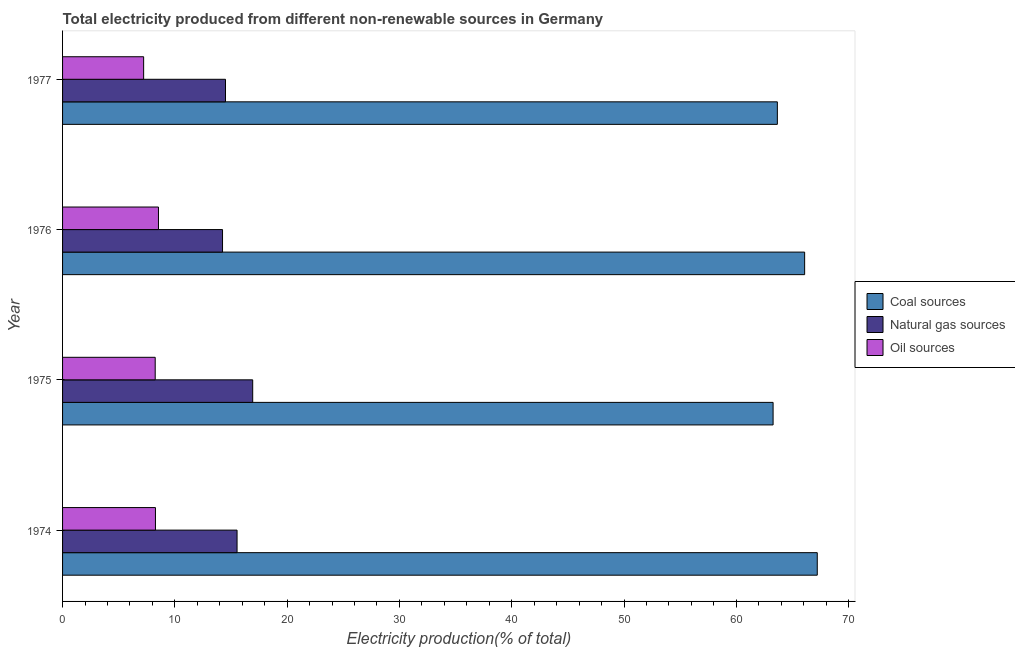How many different coloured bars are there?
Make the answer very short. 3. Are the number of bars per tick equal to the number of legend labels?
Make the answer very short. Yes. How many bars are there on the 1st tick from the top?
Your answer should be very brief. 3. In how many cases, is the number of bars for a given year not equal to the number of legend labels?
Ensure brevity in your answer.  0. What is the percentage of electricity produced by coal in 1974?
Offer a very short reply. 67.21. Across all years, what is the maximum percentage of electricity produced by coal?
Your response must be concise. 67.21. Across all years, what is the minimum percentage of electricity produced by coal?
Provide a short and direct response. 63.27. In which year was the percentage of electricity produced by coal maximum?
Give a very brief answer. 1974. In which year was the percentage of electricity produced by coal minimum?
Provide a short and direct response. 1975. What is the total percentage of electricity produced by coal in the graph?
Make the answer very short. 260.22. What is the difference between the percentage of electricity produced by natural gas in 1975 and the percentage of electricity produced by oil sources in 1977?
Give a very brief answer. 9.71. What is the average percentage of electricity produced by coal per year?
Make the answer very short. 65.06. In the year 1976, what is the difference between the percentage of electricity produced by natural gas and percentage of electricity produced by coal?
Your answer should be very brief. -51.84. What is the ratio of the percentage of electricity produced by oil sources in 1975 to that in 1976?
Ensure brevity in your answer.  0.97. What is the difference between the highest and the second highest percentage of electricity produced by coal?
Ensure brevity in your answer.  1.13. What is the difference between the highest and the lowest percentage of electricity produced by coal?
Offer a terse response. 3.93. What does the 1st bar from the top in 1974 represents?
Provide a succinct answer. Oil sources. What does the 3rd bar from the bottom in 1977 represents?
Provide a succinct answer. Oil sources. How many years are there in the graph?
Offer a terse response. 4. What is the difference between two consecutive major ticks on the X-axis?
Keep it short and to the point. 10. Does the graph contain grids?
Give a very brief answer. No. Where does the legend appear in the graph?
Your response must be concise. Center right. What is the title of the graph?
Keep it short and to the point. Total electricity produced from different non-renewable sources in Germany. Does "Agricultural Nitrous Oxide" appear as one of the legend labels in the graph?
Your answer should be compact. No. What is the label or title of the Y-axis?
Ensure brevity in your answer.  Year. What is the Electricity production(% of total) of Coal sources in 1974?
Your answer should be very brief. 67.21. What is the Electricity production(% of total) in Natural gas sources in 1974?
Give a very brief answer. 15.54. What is the Electricity production(% of total) in Oil sources in 1974?
Offer a very short reply. 8.27. What is the Electricity production(% of total) in Coal sources in 1975?
Offer a terse response. 63.27. What is the Electricity production(% of total) in Natural gas sources in 1975?
Give a very brief answer. 16.93. What is the Electricity production(% of total) in Oil sources in 1975?
Provide a short and direct response. 8.25. What is the Electricity production(% of total) of Coal sources in 1976?
Provide a short and direct response. 66.08. What is the Electricity production(% of total) of Natural gas sources in 1976?
Provide a succinct answer. 14.25. What is the Electricity production(% of total) of Oil sources in 1976?
Ensure brevity in your answer.  8.54. What is the Electricity production(% of total) of Coal sources in 1977?
Your answer should be very brief. 63.65. What is the Electricity production(% of total) in Natural gas sources in 1977?
Offer a very short reply. 14.51. What is the Electricity production(% of total) of Oil sources in 1977?
Offer a terse response. 7.22. Across all years, what is the maximum Electricity production(% of total) in Coal sources?
Your answer should be compact. 67.21. Across all years, what is the maximum Electricity production(% of total) of Natural gas sources?
Provide a succinct answer. 16.93. Across all years, what is the maximum Electricity production(% of total) of Oil sources?
Your response must be concise. 8.54. Across all years, what is the minimum Electricity production(% of total) in Coal sources?
Offer a terse response. 63.27. Across all years, what is the minimum Electricity production(% of total) in Natural gas sources?
Your answer should be compact. 14.25. Across all years, what is the minimum Electricity production(% of total) in Oil sources?
Your response must be concise. 7.22. What is the total Electricity production(% of total) in Coal sources in the graph?
Offer a very short reply. 260.22. What is the total Electricity production(% of total) in Natural gas sources in the graph?
Provide a short and direct response. 61.23. What is the total Electricity production(% of total) in Oil sources in the graph?
Ensure brevity in your answer.  32.28. What is the difference between the Electricity production(% of total) in Coal sources in 1974 and that in 1975?
Your answer should be very brief. 3.93. What is the difference between the Electricity production(% of total) of Natural gas sources in 1974 and that in 1975?
Your answer should be compact. -1.39. What is the difference between the Electricity production(% of total) in Oil sources in 1974 and that in 1975?
Your answer should be very brief. 0.02. What is the difference between the Electricity production(% of total) of Coal sources in 1974 and that in 1976?
Offer a terse response. 1.13. What is the difference between the Electricity production(% of total) of Natural gas sources in 1974 and that in 1976?
Your answer should be very brief. 1.29. What is the difference between the Electricity production(% of total) in Oil sources in 1974 and that in 1976?
Offer a terse response. -0.27. What is the difference between the Electricity production(% of total) of Coal sources in 1974 and that in 1977?
Make the answer very short. 3.56. What is the difference between the Electricity production(% of total) in Natural gas sources in 1974 and that in 1977?
Ensure brevity in your answer.  1.03. What is the difference between the Electricity production(% of total) in Oil sources in 1974 and that in 1977?
Ensure brevity in your answer.  1.05. What is the difference between the Electricity production(% of total) in Coal sources in 1975 and that in 1976?
Give a very brief answer. -2.81. What is the difference between the Electricity production(% of total) of Natural gas sources in 1975 and that in 1976?
Make the answer very short. 2.69. What is the difference between the Electricity production(% of total) in Oil sources in 1975 and that in 1976?
Ensure brevity in your answer.  -0.29. What is the difference between the Electricity production(% of total) in Coal sources in 1975 and that in 1977?
Provide a succinct answer. -0.38. What is the difference between the Electricity production(% of total) in Natural gas sources in 1975 and that in 1977?
Ensure brevity in your answer.  2.42. What is the difference between the Electricity production(% of total) in Oil sources in 1975 and that in 1977?
Offer a very short reply. 1.03. What is the difference between the Electricity production(% of total) of Coal sources in 1976 and that in 1977?
Keep it short and to the point. 2.43. What is the difference between the Electricity production(% of total) in Natural gas sources in 1976 and that in 1977?
Provide a succinct answer. -0.26. What is the difference between the Electricity production(% of total) in Oil sources in 1976 and that in 1977?
Keep it short and to the point. 1.32. What is the difference between the Electricity production(% of total) of Coal sources in 1974 and the Electricity production(% of total) of Natural gas sources in 1975?
Make the answer very short. 50.28. What is the difference between the Electricity production(% of total) of Coal sources in 1974 and the Electricity production(% of total) of Oil sources in 1975?
Offer a very short reply. 58.96. What is the difference between the Electricity production(% of total) of Natural gas sources in 1974 and the Electricity production(% of total) of Oil sources in 1975?
Make the answer very short. 7.29. What is the difference between the Electricity production(% of total) of Coal sources in 1974 and the Electricity production(% of total) of Natural gas sources in 1976?
Provide a short and direct response. 52.96. What is the difference between the Electricity production(% of total) in Coal sources in 1974 and the Electricity production(% of total) in Oil sources in 1976?
Your answer should be very brief. 58.67. What is the difference between the Electricity production(% of total) of Natural gas sources in 1974 and the Electricity production(% of total) of Oil sources in 1976?
Offer a very short reply. 7. What is the difference between the Electricity production(% of total) of Coal sources in 1974 and the Electricity production(% of total) of Natural gas sources in 1977?
Offer a very short reply. 52.7. What is the difference between the Electricity production(% of total) in Coal sources in 1974 and the Electricity production(% of total) in Oil sources in 1977?
Your response must be concise. 59.99. What is the difference between the Electricity production(% of total) of Natural gas sources in 1974 and the Electricity production(% of total) of Oil sources in 1977?
Ensure brevity in your answer.  8.32. What is the difference between the Electricity production(% of total) in Coal sources in 1975 and the Electricity production(% of total) in Natural gas sources in 1976?
Provide a short and direct response. 49.03. What is the difference between the Electricity production(% of total) of Coal sources in 1975 and the Electricity production(% of total) of Oil sources in 1976?
Keep it short and to the point. 54.73. What is the difference between the Electricity production(% of total) in Natural gas sources in 1975 and the Electricity production(% of total) in Oil sources in 1976?
Make the answer very short. 8.39. What is the difference between the Electricity production(% of total) in Coal sources in 1975 and the Electricity production(% of total) in Natural gas sources in 1977?
Offer a terse response. 48.76. What is the difference between the Electricity production(% of total) in Coal sources in 1975 and the Electricity production(% of total) in Oil sources in 1977?
Keep it short and to the point. 56.05. What is the difference between the Electricity production(% of total) of Natural gas sources in 1975 and the Electricity production(% of total) of Oil sources in 1977?
Make the answer very short. 9.71. What is the difference between the Electricity production(% of total) of Coal sources in 1976 and the Electricity production(% of total) of Natural gas sources in 1977?
Provide a succinct answer. 51.57. What is the difference between the Electricity production(% of total) of Coal sources in 1976 and the Electricity production(% of total) of Oil sources in 1977?
Ensure brevity in your answer.  58.86. What is the difference between the Electricity production(% of total) in Natural gas sources in 1976 and the Electricity production(% of total) in Oil sources in 1977?
Offer a terse response. 7.02. What is the average Electricity production(% of total) of Coal sources per year?
Offer a very short reply. 65.05. What is the average Electricity production(% of total) of Natural gas sources per year?
Give a very brief answer. 15.31. What is the average Electricity production(% of total) in Oil sources per year?
Keep it short and to the point. 8.07. In the year 1974, what is the difference between the Electricity production(% of total) in Coal sources and Electricity production(% of total) in Natural gas sources?
Provide a short and direct response. 51.67. In the year 1974, what is the difference between the Electricity production(% of total) in Coal sources and Electricity production(% of total) in Oil sources?
Ensure brevity in your answer.  58.94. In the year 1974, what is the difference between the Electricity production(% of total) in Natural gas sources and Electricity production(% of total) in Oil sources?
Keep it short and to the point. 7.27. In the year 1975, what is the difference between the Electricity production(% of total) of Coal sources and Electricity production(% of total) of Natural gas sources?
Keep it short and to the point. 46.34. In the year 1975, what is the difference between the Electricity production(% of total) of Coal sources and Electricity production(% of total) of Oil sources?
Provide a short and direct response. 55.03. In the year 1975, what is the difference between the Electricity production(% of total) in Natural gas sources and Electricity production(% of total) in Oil sources?
Offer a terse response. 8.68. In the year 1976, what is the difference between the Electricity production(% of total) of Coal sources and Electricity production(% of total) of Natural gas sources?
Offer a very short reply. 51.84. In the year 1976, what is the difference between the Electricity production(% of total) of Coal sources and Electricity production(% of total) of Oil sources?
Make the answer very short. 57.54. In the year 1976, what is the difference between the Electricity production(% of total) in Natural gas sources and Electricity production(% of total) in Oil sources?
Make the answer very short. 5.71. In the year 1977, what is the difference between the Electricity production(% of total) in Coal sources and Electricity production(% of total) in Natural gas sources?
Offer a very short reply. 49.14. In the year 1977, what is the difference between the Electricity production(% of total) in Coal sources and Electricity production(% of total) in Oil sources?
Offer a very short reply. 56.43. In the year 1977, what is the difference between the Electricity production(% of total) of Natural gas sources and Electricity production(% of total) of Oil sources?
Make the answer very short. 7.29. What is the ratio of the Electricity production(% of total) in Coal sources in 1974 to that in 1975?
Your answer should be very brief. 1.06. What is the ratio of the Electricity production(% of total) of Natural gas sources in 1974 to that in 1975?
Offer a very short reply. 0.92. What is the ratio of the Electricity production(% of total) of Oil sources in 1974 to that in 1975?
Your answer should be compact. 1. What is the ratio of the Electricity production(% of total) in Coal sources in 1974 to that in 1976?
Offer a terse response. 1.02. What is the ratio of the Electricity production(% of total) of Natural gas sources in 1974 to that in 1976?
Your answer should be very brief. 1.09. What is the ratio of the Electricity production(% of total) in Oil sources in 1974 to that in 1976?
Offer a terse response. 0.97. What is the ratio of the Electricity production(% of total) of Coal sources in 1974 to that in 1977?
Your answer should be very brief. 1.06. What is the ratio of the Electricity production(% of total) of Natural gas sources in 1974 to that in 1977?
Keep it short and to the point. 1.07. What is the ratio of the Electricity production(% of total) of Oil sources in 1974 to that in 1977?
Keep it short and to the point. 1.15. What is the ratio of the Electricity production(% of total) of Coal sources in 1975 to that in 1976?
Your answer should be compact. 0.96. What is the ratio of the Electricity production(% of total) in Natural gas sources in 1975 to that in 1976?
Give a very brief answer. 1.19. What is the ratio of the Electricity production(% of total) of Oil sources in 1975 to that in 1976?
Provide a short and direct response. 0.97. What is the ratio of the Electricity production(% of total) in Coal sources in 1975 to that in 1977?
Your response must be concise. 0.99. What is the ratio of the Electricity production(% of total) of Natural gas sources in 1975 to that in 1977?
Ensure brevity in your answer.  1.17. What is the ratio of the Electricity production(% of total) of Oil sources in 1975 to that in 1977?
Provide a succinct answer. 1.14. What is the ratio of the Electricity production(% of total) of Coal sources in 1976 to that in 1977?
Provide a short and direct response. 1.04. What is the ratio of the Electricity production(% of total) in Natural gas sources in 1976 to that in 1977?
Offer a terse response. 0.98. What is the ratio of the Electricity production(% of total) in Oil sources in 1976 to that in 1977?
Your answer should be compact. 1.18. What is the difference between the highest and the second highest Electricity production(% of total) of Coal sources?
Provide a short and direct response. 1.13. What is the difference between the highest and the second highest Electricity production(% of total) of Natural gas sources?
Provide a short and direct response. 1.39. What is the difference between the highest and the second highest Electricity production(% of total) of Oil sources?
Your answer should be compact. 0.27. What is the difference between the highest and the lowest Electricity production(% of total) of Coal sources?
Keep it short and to the point. 3.93. What is the difference between the highest and the lowest Electricity production(% of total) in Natural gas sources?
Your response must be concise. 2.69. What is the difference between the highest and the lowest Electricity production(% of total) in Oil sources?
Provide a succinct answer. 1.32. 